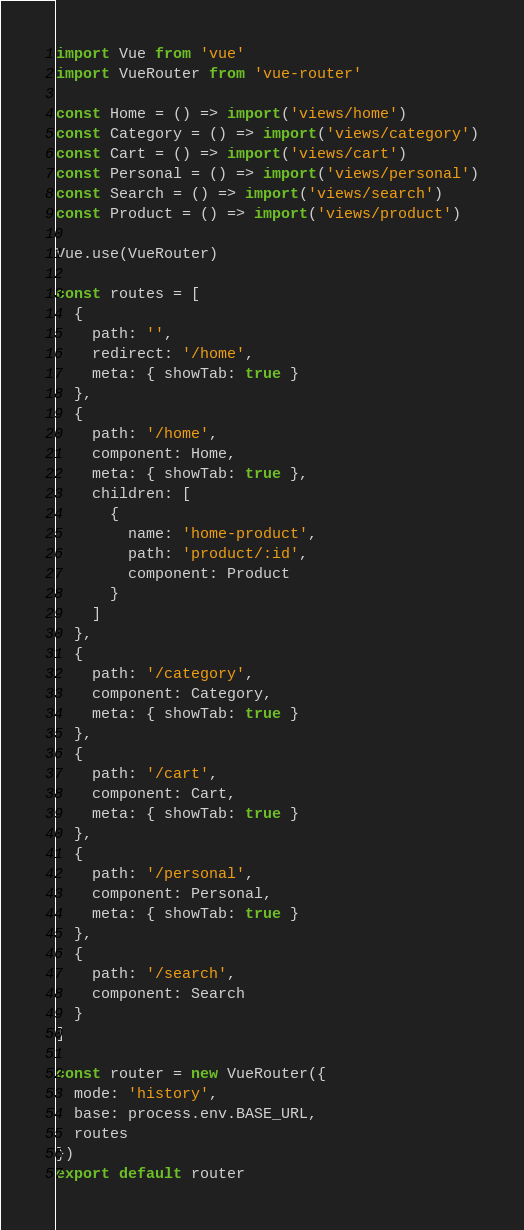Convert code to text. <code><loc_0><loc_0><loc_500><loc_500><_JavaScript_>import Vue from 'vue'
import VueRouter from 'vue-router'

const Home = () => import('views/home')
const Category = () => import('views/category')
const Cart = () => import('views/cart')
const Personal = () => import('views/personal')
const Search = () => import('views/search')
const Product = () => import('views/product')

Vue.use(VueRouter)

const routes = [
  {
    path: '',
    redirect: '/home',
    meta: { showTab: true }
  },
  {
    path: '/home',
    component: Home,
    meta: { showTab: true },
    children: [
      {
        name: 'home-product',
        path: 'product/:id',
        component: Product
      }
    ]
  },
  {
    path: '/category',
    component: Category,
    meta: { showTab: true }
  },
  {
    path: '/cart',
    component: Cart,
    meta: { showTab: true }
  },
  {
    path: '/personal',
    component: Personal,
    meta: { showTab: true }
  },
  {
    path: '/search',
    component: Search
  }
]

const router = new VueRouter({
  mode: 'history',
  base: process.env.BASE_URL,
  routes
})
export default router
</code> 